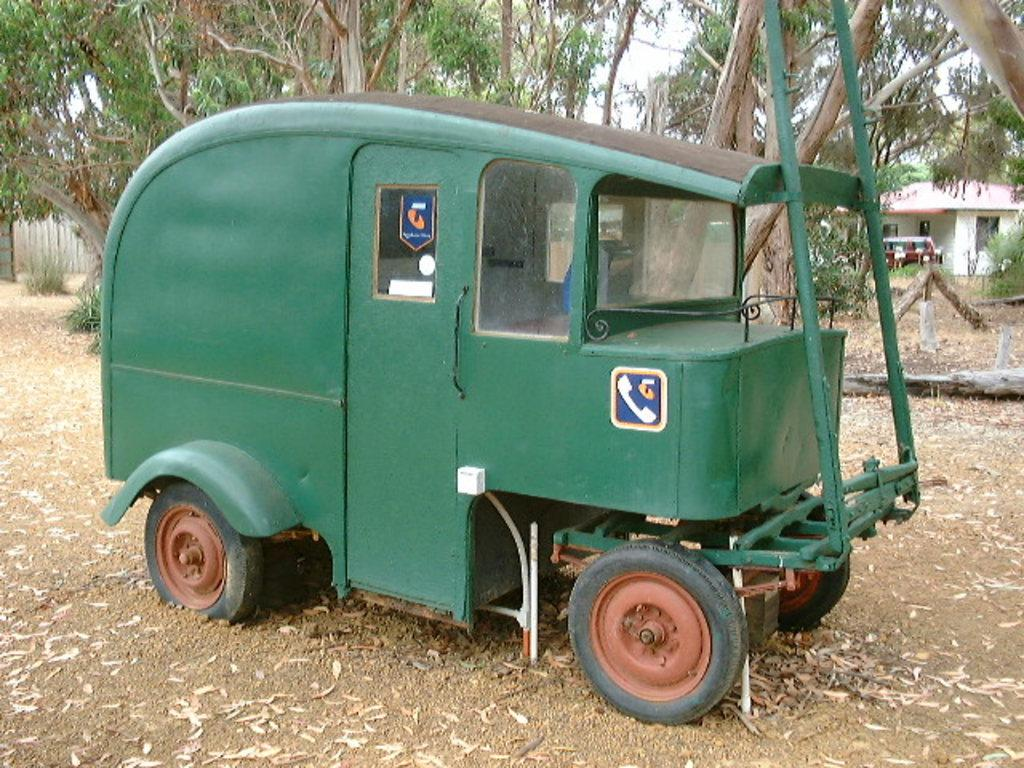What is located on the ground in the image? There is a vehicle on the ground in the image. What type of natural vegetation can be seen in the image? There are trees visible in the image. What type of structure is present in the image? There is a building in the image. What else can be seen in front of the building? There is another vehicle in front of the building. What is visible in the background of the image? The sky is visible in the background of the image. What riddle is the vehicle trying to solve in the image? There is no riddle present in the image; it is a scene featuring vehicles and a building. Can you tell me how the vehicle is playing in the image? There is no indication that the vehicle is playing in the image; it is stationary on the ground. 